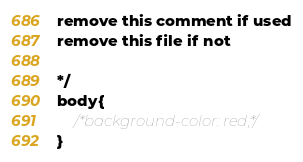<code> <loc_0><loc_0><loc_500><loc_500><_CSS_>
remove this comment if used
remove this file if not

*/
body{
	/*background-color: red;*/
}</code> 